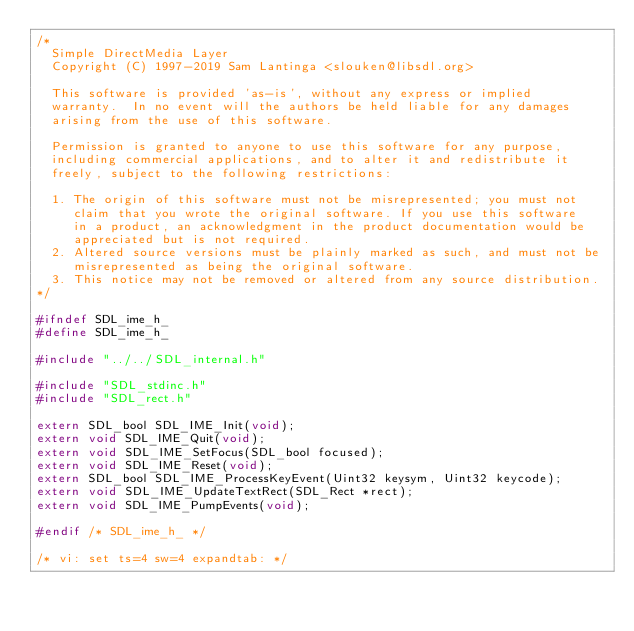<code> <loc_0><loc_0><loc_500><loc_500><_C_>/*
  Simple DirectMedia Layer
  Copyright (C) 1997-2019 Sam Lantinga <slouken@libsdl.org>

  This software is provided 'as-is', without any express or implied
  warranty.  In no event will the authors be held liable for any damages
  arising from the use of this software.

  Permission is granted to anyone to use this software for any purpose,
  including commercial applications, and to alter it and redistribute it
  freely, subject to the following restrictions:

  1. The origin of this software must not be misrepresented; you must not
     claim that you wrote the original software. If you use this software
     in a product, an acknowledgment in the product documentation would be
     appreciated but is not required.
  2. Altered source versions must be plainly marked as such, and must not be
     misrepresented as being the original software.
  3. This notice may not be removed or altered from any source distribution.
*/

#ifndef SDL_ime_h_
#define SDL_ime_h_

#include "../../SDL_internal.h"

#include "SDL_stdinc.h"
#include "SDL_rect.h"

extern SDL_bool SDL_IME_Init(void);
extern void SDL_IME_Quit(void);
extern void SDL_IME_SetFocus(SDL_bool focused);
extern void SDL_IME_Reset(void);
extern SDL_bool SDL_IME_ProcessKeyEvent(Uint32 keysym, Uint32 keycode);
extern void SDL_IME_UpdateTextRect(SDL_Rect *rect);
extern void SDL_IME_PumpEvents(void);

#endif /* SDL_ime_h_ */

/* vi: set ts=4 sw=4 expandtab: */
</code> 